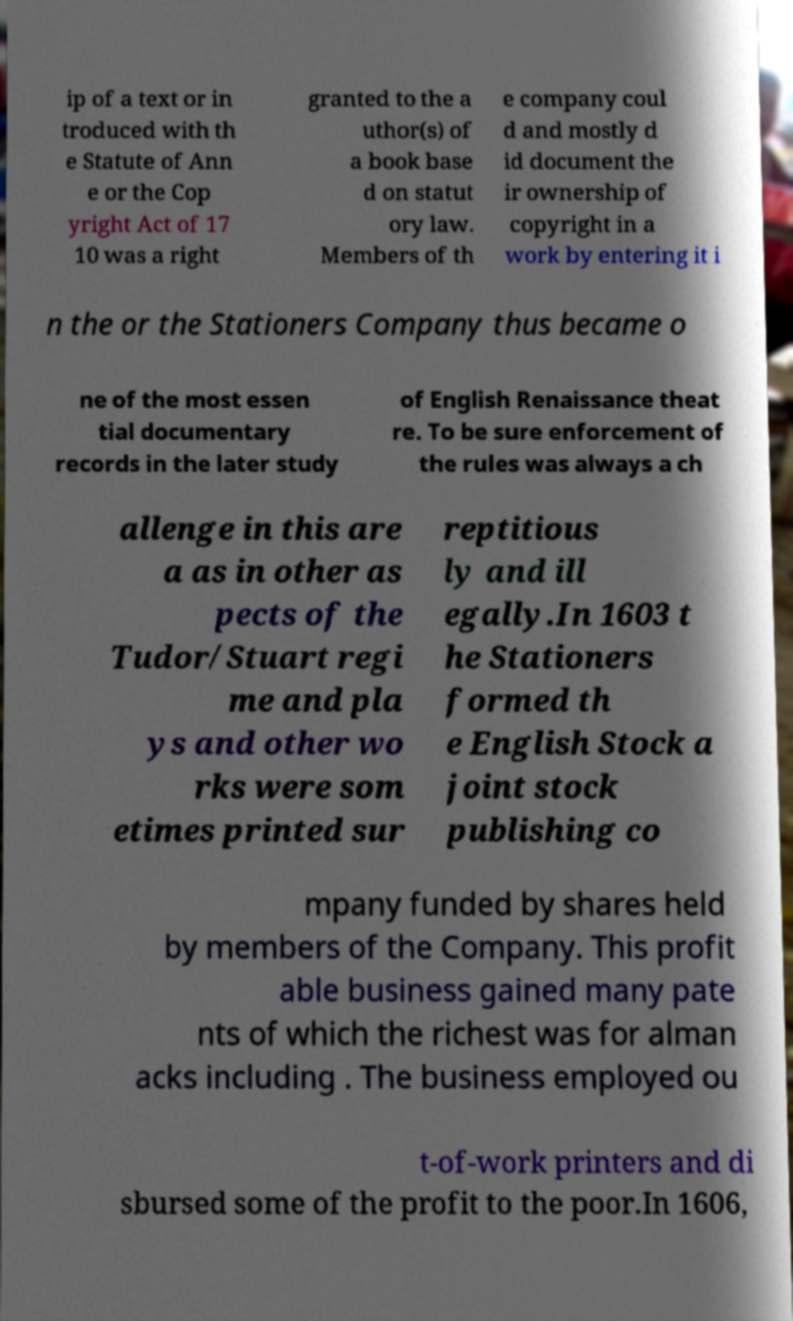There's text embedded in this image that I need extracted. Can you transcribe it verbatim? ip of a text or in troduced with th e Statute of Ann e or the Cop yright Act of 17 10 was a right granted to the a uthor(s) of a book base d on statut ory law. Members of th e company coul d and mostly d id document the ir ownership of copyright in a work by entering it i n the or the Stationers Company thus became o ne of the most essen tial documentary records in the later study of English Renaissance theat re. To be sure enforcement of the rules was always a ch allenge in this are a as in other as pects of the Tudor/Stuart regi me and pla ys and other wo rks were som etimes printed sur reptitious ly and ill egally.In 1603 t he Stationers formed th e English Stock a joint stock publishing co mpany funded by shares held by members of the Company. This profit able business gained many pate nts of which the richest was for alman acks including . The business employed ou t-of-work printers and di sbursed some of the profit to the poor.In 1606, 